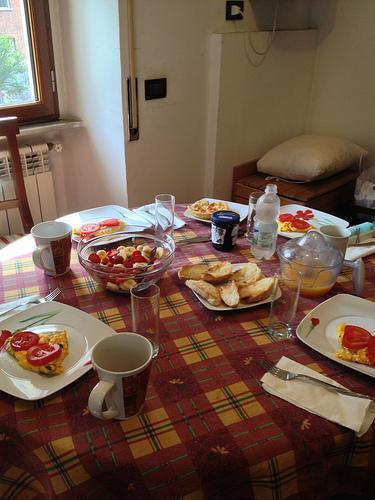How many glasses are there?
Give a very brief answer. 4. 